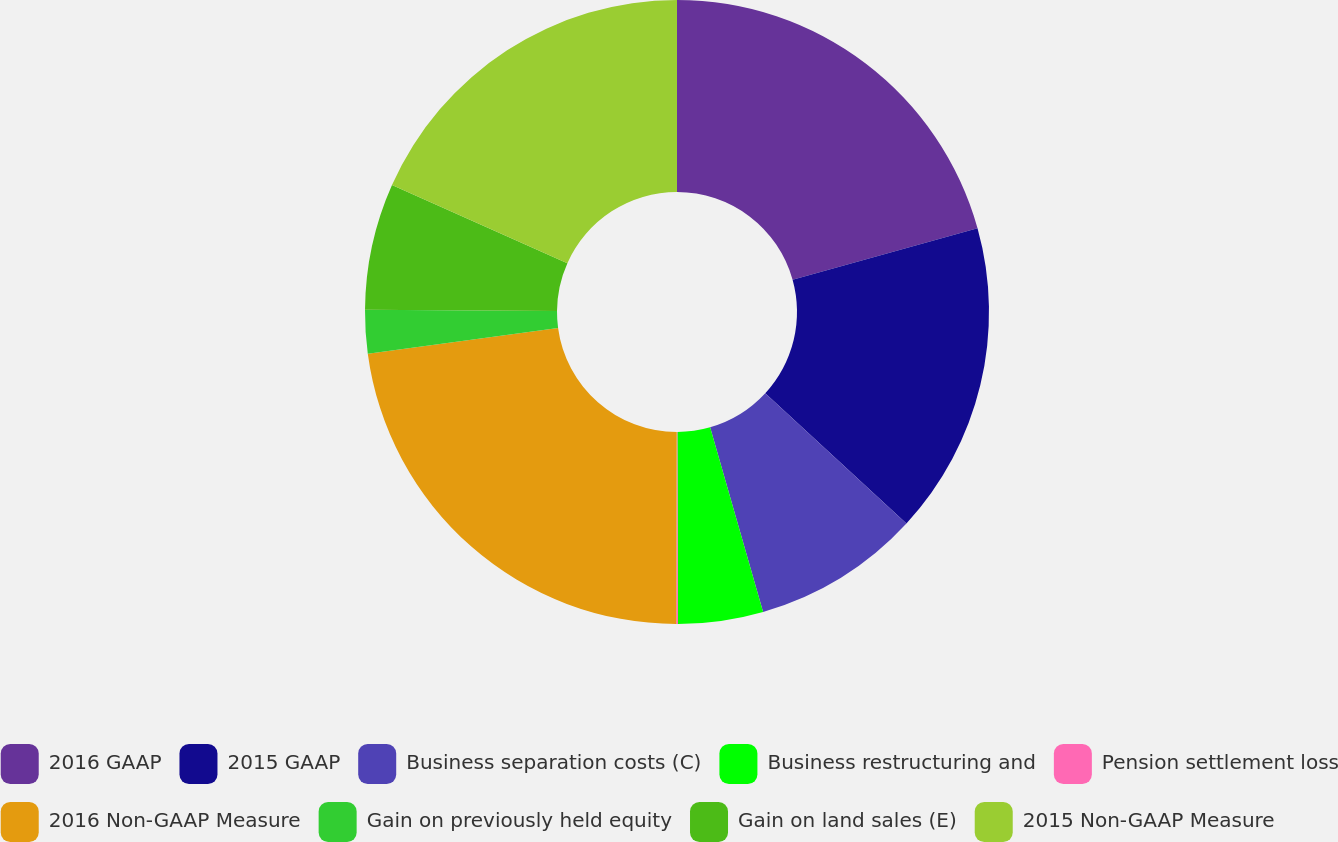<chart> <loc_0><loc_0><loc_500><loc_500><pie_chart><fcel>2016 GAAP<fcel>2015 GAAP<fcel>Business separation costs (C)<fcel>Business restructuring and<fcel>Pension settlement loss<fcel>2016 Non-GAAP Measure<fcel>Gain on previously held equity<fcel>Gain on land sales (E)<fcel>2015 Non-GAAP Measure<nl><fcel>20.67%<fcel>16.18%<fcel>8.7%<fcel>4.4%<fcel>0.09%<fcel>22.83%<fcel>2.25%<fcel>6.55%<fcel>18.33%<nl></chart> 